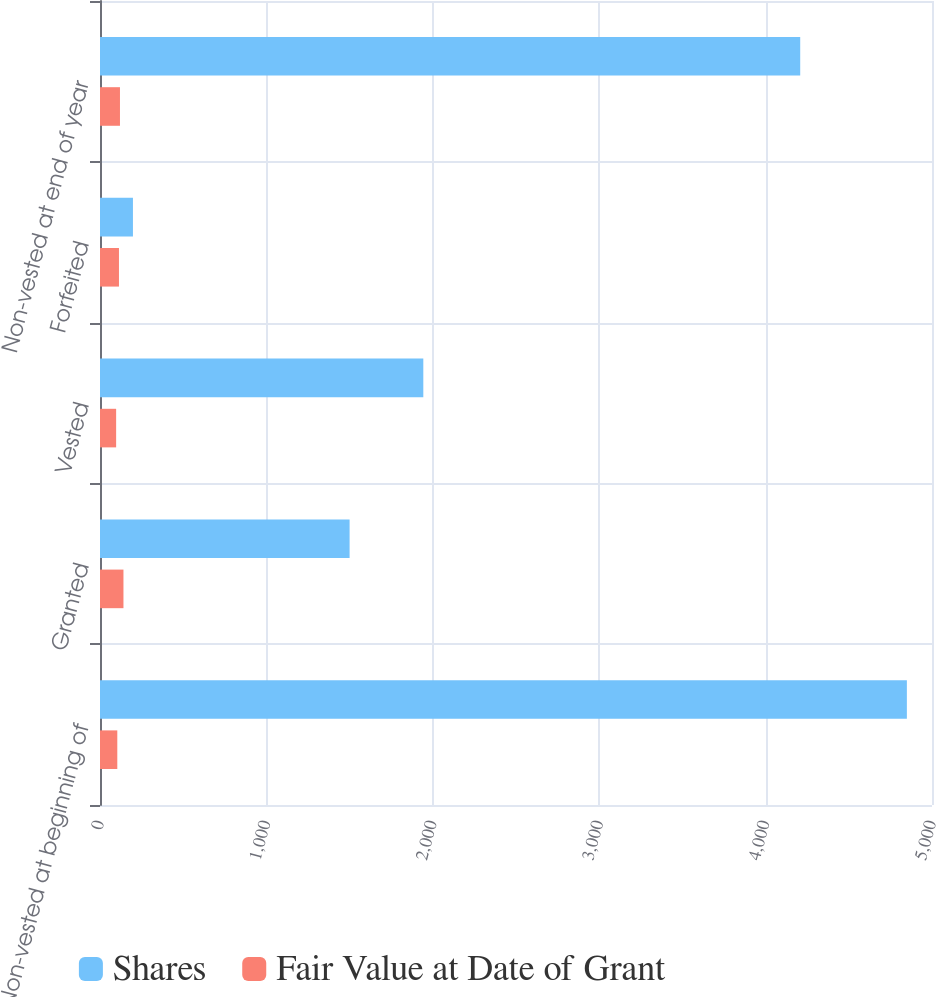Convert chart to OTSL. <chart><loc_0><loc_0><loc_500><loc_500><stacked_bar_chart><ecel><fcel>Non-vested at beginning of<fcel>Granted<fcel>Vested<fcel>Forfeited<fcel>Non-vested at end of year<nl><fcel>Shares<fcel>4849<fcel>1500<fcel>1943<fcel>198<fcel>4208<nl><fcel>Fair Value at Date of Grant<fcel>104<fcel>141<fcel>97<fcel>114<fcel>120<nl></chart> 